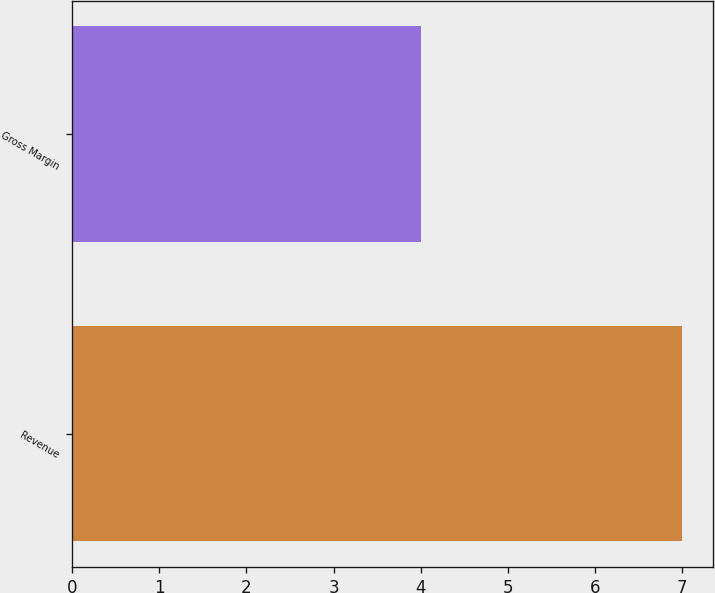Convert chart to OTSL. <chart><loc_0><loc_0><loc_500><loc_500><bar_chart><fcel>Revenue<fcel>Gross Margin<nl><fcel>7<fcel>4<nl></chart> 